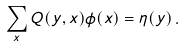<formula> <loc_0><loc_0><loc_500><loc_500>\sum _ { x } Q ( y , x ) \phi ( x ) = \eta ( y ) \, .</formula> 